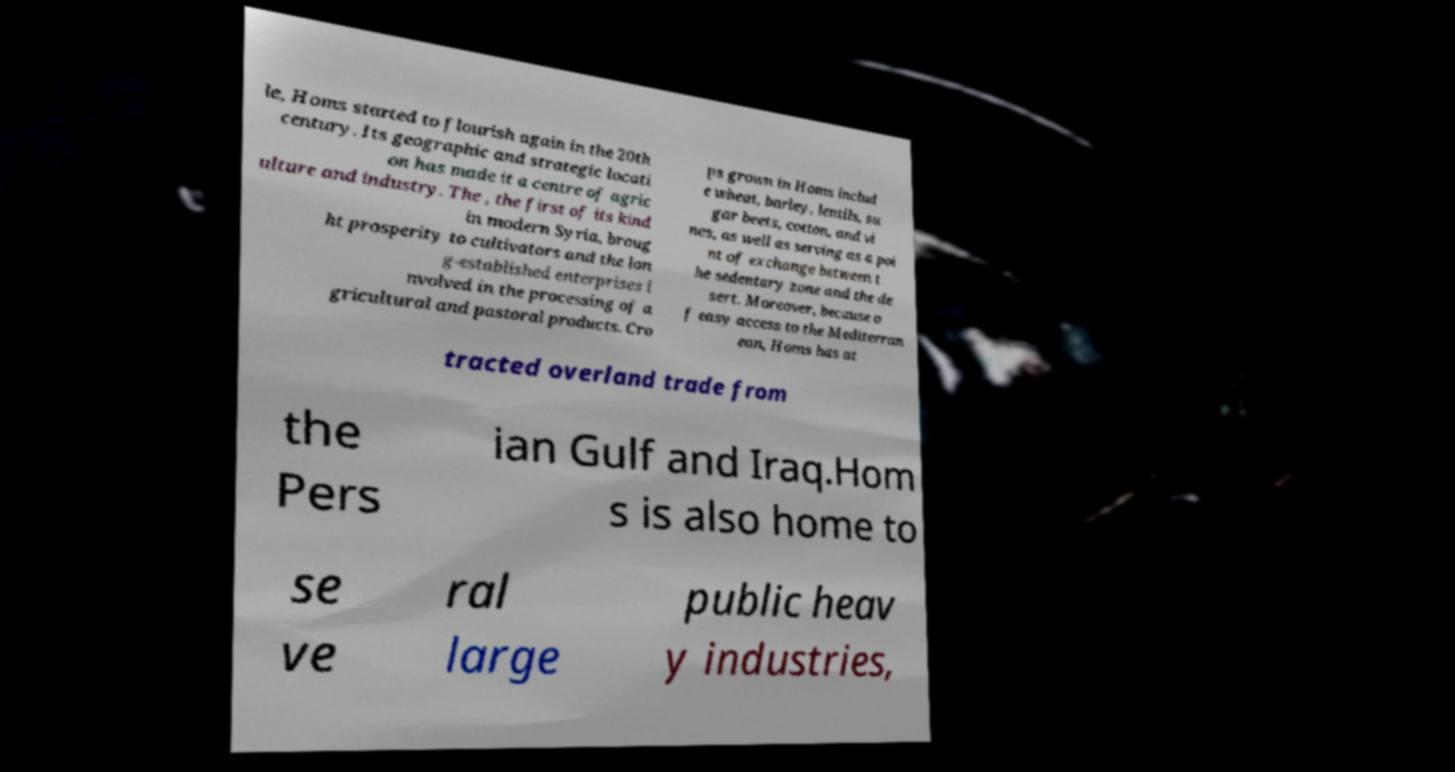Please read and relay the text visible in this image. What does it say? le, Homs started to flourish again in the 20th century. Its geographic and strategic locati on has made it a centre of agric ulture and industry. The , the first of its kind in modern Syria, broug ht prosperity to cultivators and the lon g-established enterprises i nvolved in the processing of a gricultural and pastoral products. Cro ps grown in Homs includ e wheat, barley, lentils, su gar beets, cotton, and vi nes, as well as serving as a poi nt of exchange between t he sedentary zone and the de sert. Moreover, because o f easy access to the Mediterran ean, Homs has at tracted overland trade from the Pers ian Gulf and Iraq.Hom s is also home to se ve ral large public heav y industries, 